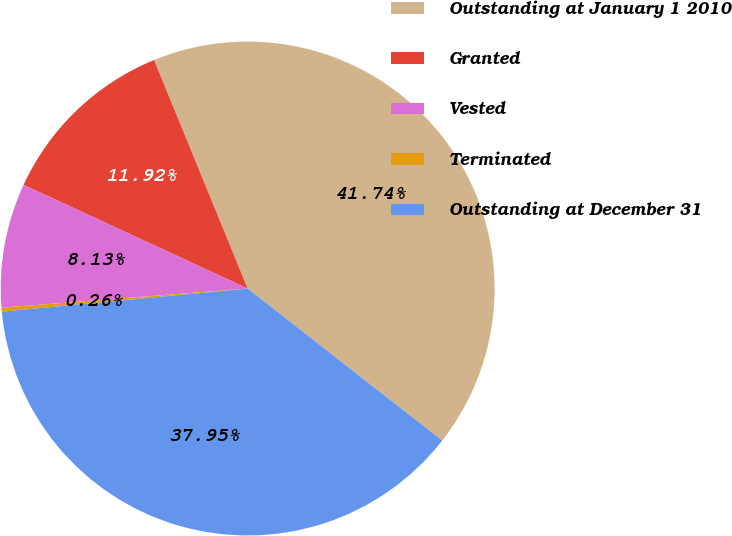Convert chart. <chart><loc_0><loc_0><loc_500><loc_500><pie_chart><fcel>Outstanding at January 1 2010<fcel>Granted<fcel>Vested<fcel>Terminated<fcel>Outstanding at December 31<nl><fcel>41.74%<fcel>11.92%<fcel>8.13%<fcel>0.26%<fcel>37.95%<nl></chart> 